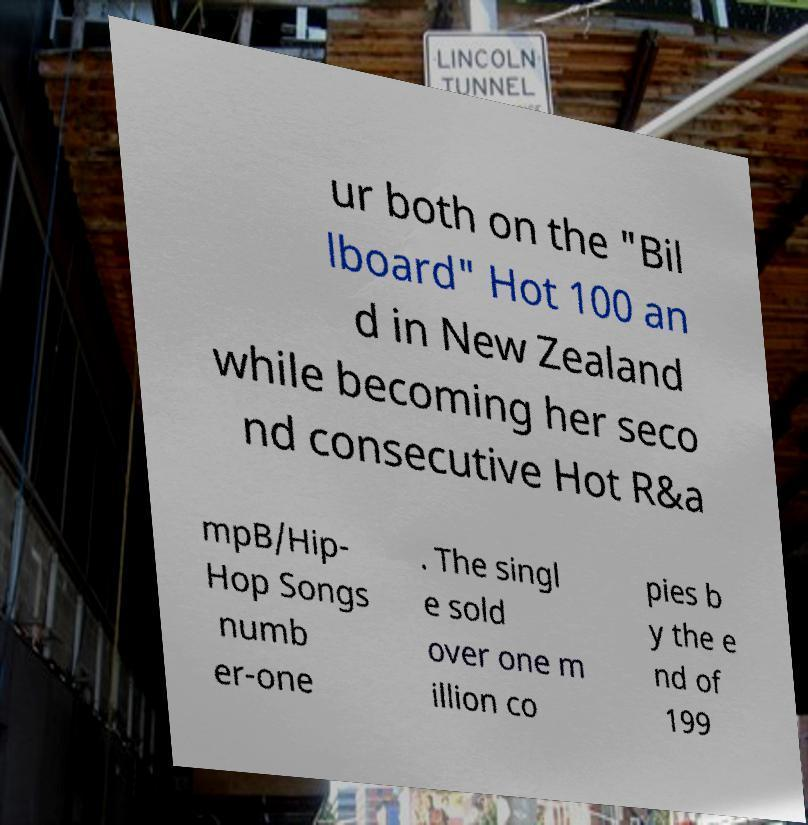Can you read and provide the text displayed in the image?This photo seems to have some interesting text. Can you extract and type it out for me? ur both on the "Bil lboard" Hot 100 an d in New Zealand while becoming her seco nd consecutive Hot R&a mpB/Hip- Hop Songs numb er-one . The singl e sold over one m illion co pies b y the e nd of 199 